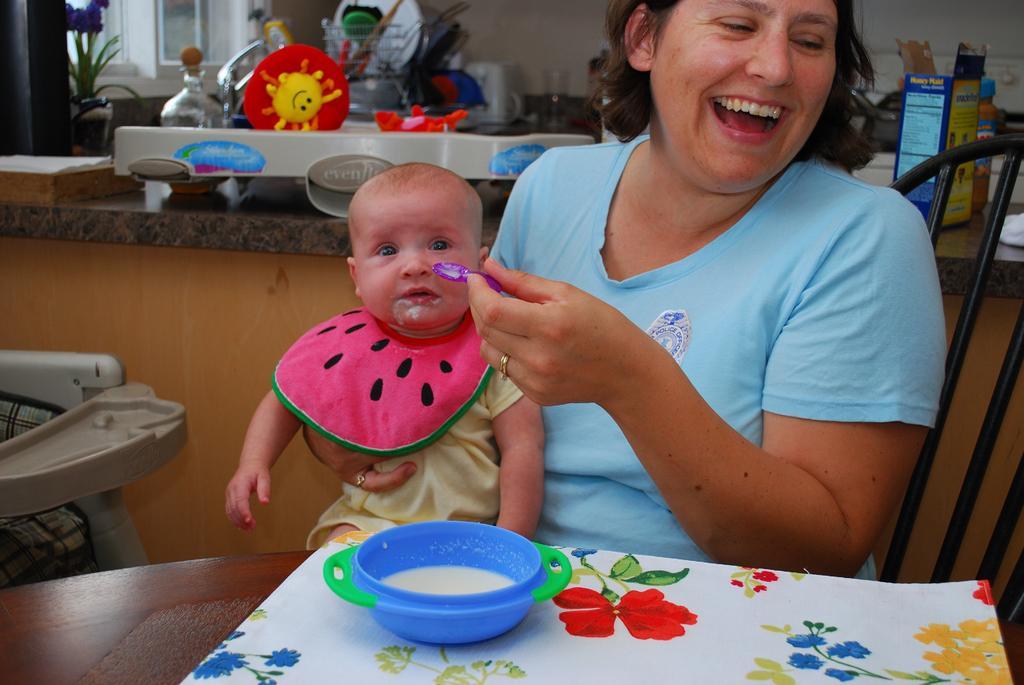In one or two sentences, can you explain what this image depicts? In this image we can see a lady sitting and feeding a baby, before her there is a table and we can see a bowl containing food and a napkin placed on the table. In the background there is a chair and a counter table. We can see things placed on the counter table. On the left there is a house plant and a window. There is a wall. 